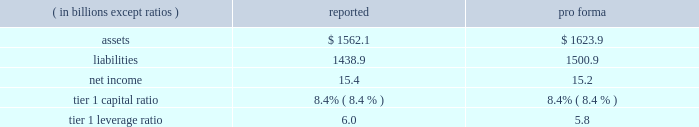Notes to consolidated financial statements jpmorgan chase & co .
150 jpmorgan chase & co .
/ 2007 annual report expected loss modeling in 2006 , the firm restructured four multi-seller conduits that it administers .
The restructurings included enhancing the firm 2019s expected loss model .
In determining the primary beneficiary of the conduits it administers , the firm uses a monte carlo 2013based model to estimate the expected losses of each of the conduits and considers the rela- tive rights and obligations of each of the variable interest holders .
The variability to be considered in the modeling of expected losses is based on the design of the entity .
The firm 2019s traditional multi-seller conduits are designed to pass credit risk , not liquidity risk , to its vari- able interest holders , as the assets are intended to be held in the conduit for the longer term .
Under fin 46r , the firm is required to run the monte carlo-based expected loss model each time a reconsideration event occurs .
In applying this guidance to the conduits , the following events are considered to be reconsideration events as they could affect the determination of the primary beneficiary of the conduits : 2022 new deals , including the issuance of new or additional variable interests ( credit support , liquidity facilities , etc ) ; 2022 changes in usage , including the change in the level of outstand- ing variable interests ( credit support , liquidity facilities , etc ) ; 2022 modifications of asset purchase agreements ; and 2022 sales of interests held by the primary beneficiary .
From an operational perspective , the firm does not run its monte carlo-based expected loss model every time there is a reconsidera- tion event due to the frequency of their occurrence .
Instead , the firm runs its expected loss model each quarter and includes a growth assumption for each conduit to ensure that a sufficient amount of elns exists for each conduit at any point during the quarter .
As part of its normal quarterly model review , the firm reassesses the underlying assumptions and inputs of the expected loss model .
During the second half of 2007 , certain assumptions used in the model were adjusted to reflect the then current market conditions .
Specifically , risk ratings and loss given default assumptions relating to residential subprime mortgage exposures were modified .
For other nonmortgage-related asset classes , the firm determined that the assumptions in the model required little adjustment .
As a result of the updates to the model , during the fourth quarter of 2007 the terms of the elns were renegotiated to increase the level of commit- ment and funded amounts to be provided by the eln holders .
The total amount of expected loss notes outstanding at december 31 , 2007 and 2006 , were $ 130 million and $ 54 million , respectively .
Management concluded that the model assumptions used were reflective of market participant 2019s assumptions and appropriately considered the probability of a recurrence of recent market events .
Qualitative considerations the multi-seller conduits are primarily designed to provide an efficient means for clients to access the commercial paper market .
The firm believes the conduits effectively disperse risk among all parties and that the preponderance of economic risk in the firm 2019s multi-seller conduits is not held by jpmorgan chase .
The percentage of assets in the multi-seller conduits that the firm views as client-related represent 99% ( 99 % ) and 98% ( 98 % ) of the total conduits 2019 holdings at december 31 , 2007 and 2006 , respectively .
Consolidated sensitivity analysis on capital it is possible that the firm could be required to consolidate a vie if it were determined that the firm became the primary beneficiary of the vie under the provisions of fin 46r .
The factors involved in making the determination of whether or not a vie should be consolidated are dis- cussed above and in note 1 on page 108 of this annual report .
The table below shows the impact on the firm 2019s reported assets , liabilities , net income , tier 1 capital ratio and tier 1 leverage ratio if the firm were required to consolidate all of the multi-seller conduits that it administers .
As of or for the year ending december 31 , 2007 .
The firm could fund purchases of assets from vies should it become necessary .
Investor intermediation as a financial intermediary , the firm creates certain types of vies and also structures transactions , typically derivative structures , with these vies to meet investor needs .
The firm may also provide liquidity and other support .
The risks inherent in the derivative instruments or liq- uidity commitments are managed similarly to other credit , market or liquidity risks to which the firm is exposed .
The principal types of vies for which the firm is engaged in these structuring activities are municipal bond vehicles , credit-linked note vehicles and collateralized debt obligation vehicles .
Municipal bond vehicles the firm has created a series of secondary market trusts that provide short-term investors with qualifying tax-exempt investments , and that allow investors in tax-exempt securities to finance their investments at short-term tax-exempt rates .
In a typical transaction , the vehicle pur- chases fixed-rate longer-term highly rated municipal bonds and funds the purchase by issuing two types of securities : ( 1 ) putable floating- rate certificates and ( 2 ) inverse floating-rate residual interests ( 201cresid- ual interests 201d ) .
The maturity of each of the putable floating-rate certifi- cates and the residual interests is equal to the life of the vehicle , while the maturity of the underlying municipal bonds is longer .
Holders of the putable floating-rate certificates may 201cput 201d , or tender , the certifi- cates if the remarketing agent cannot successfully remarket the float- ing-rate certificates to another investor .
A liquidity facility conditionally obligates the liquidity provider to fund the purchase of the tendered floating-rate certificates .
Upon termination of the vehicle , if the pro- ceeds from the sale of the underlying municipal bonds are not suffi- cient to repay the liquidity facility , the liquidity provider has recourse either to excess collateralization in the vehicle or the residual interest holders for reimbursement .
The third-party holders of the residual interests in these vehicles could experience losses if the face amount of the putable floating-rate cer- tificates exceeds the market value of the municipal bonds upon termi- nation of the vehicle .
Certain vehicles require a smaller initial invest- ment by the residual interest holders and thus do not result in excess collateralization .
For these vehicles there exists a reimbursement obli- .
In 2007 what was the reported debt to the assets ratio? 
Computations: (1438.9 / 1562.1)
Answer: 0.92113. 